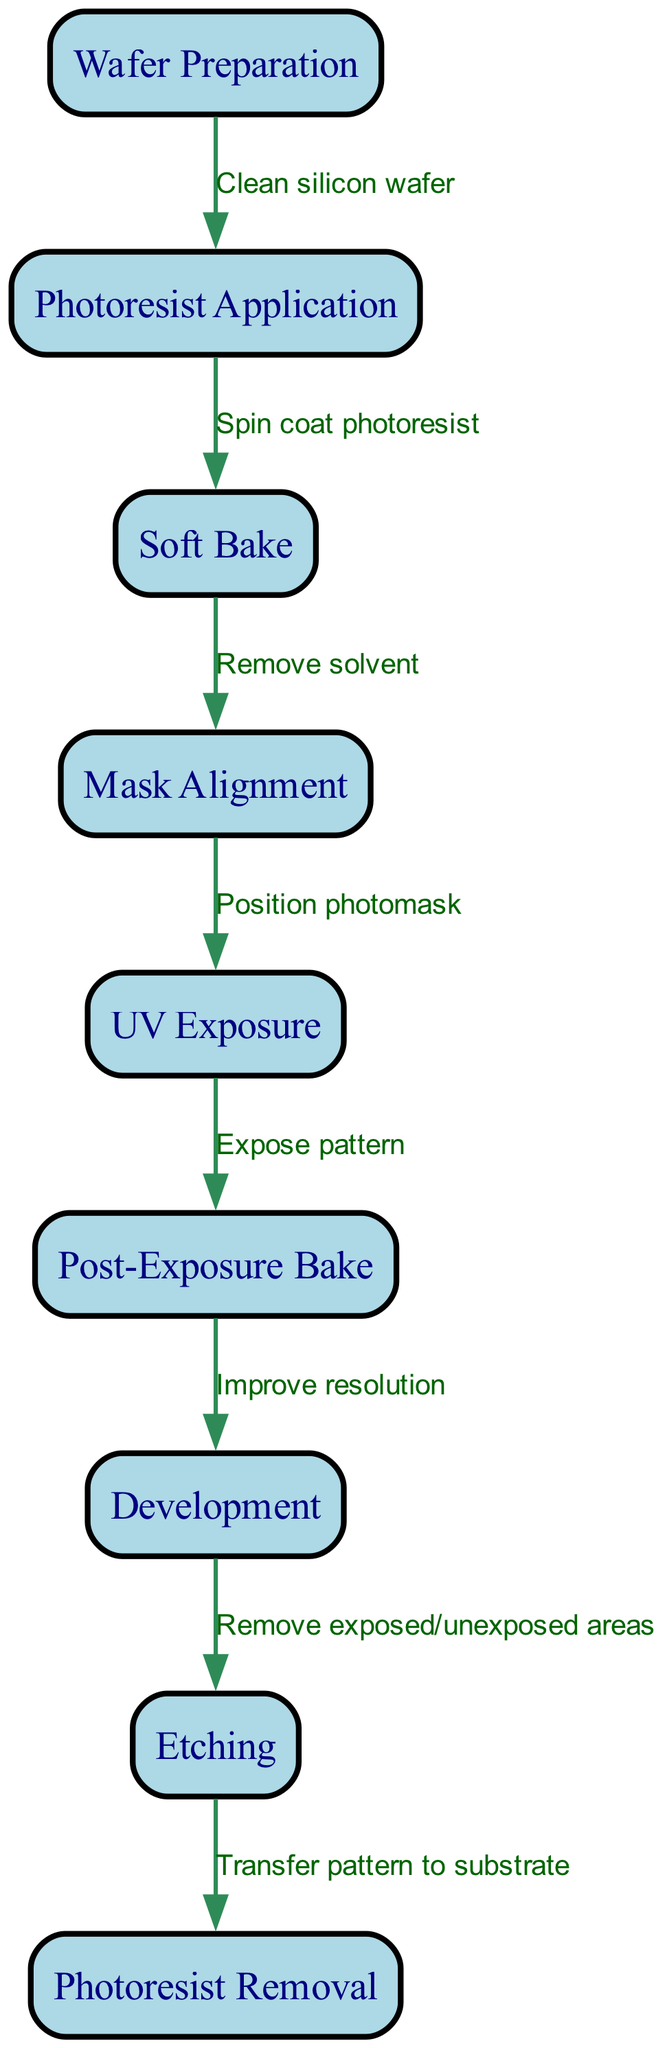What is the starting point of the photolithography process? The diagram indicates that the first node is "Wafer Preparation," which initiates the photolithography process.
Answer: Wafer Preparation How many nodes are present in the diagram? By counting each node in the diagram, we identify that there are a total of nine nodes representing various steps in the photolithography process.
Answer: 9 What step follows "Soft Bake"? The flow chart indicates that after "Soft Bake," the next step is "Mask Alignment," which is directly connected to the previous node.
Answer: Mask Alignment What is the last step in the photolithography process? The final step in the process is indicated as "Photoresist Removal," which is the last node in the flow chart, completing the process cycle.
Answer: Photoresist Removal What is the relationship between "UV Exposure" and "Post-Exposure Bake"? In the flow chart, "UV Exposure" leads directly to "Post-Exposure Bake," indicating that once the exposure step is complete, the next is the baking process to improve the resolution.
Answer: Expose pattern What type of operation occurs before "Development"? The diagram shows that "Post-Exposure Bake" happens prior to "Development," which improves the resolution of the patterns exposed on the photoresist.
Answer: Improve resolution Which step involves the removal of solvent? The edge between "Soft Bake" and "Mask Alignment" specifies that the removal of solvent occurs during the "Soft Bake" process, ensuring the photoresist is properly prepared.
Answer: Remove solvent How many edges connect the nodes in the diagram? Counting the edges that connect nodes reveals there are a total of eight edges describing the relationships between the various steps in the photolithography process.
Answer: 8 What action is defined before "Etching"? The flow chart shows that before "Etching," the node "Development" indicates the action of removing exposed and unexposed areas from the photoresist.
Answer: Remove exposed/unexposed areas 